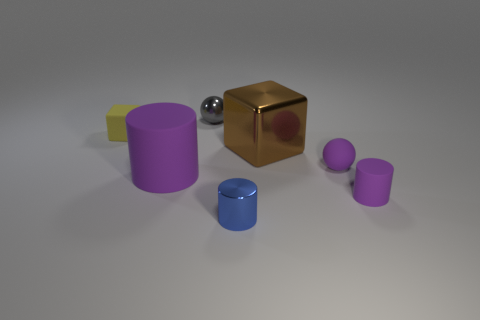Add 2 large cylinders. How many objects exist? 9 Subtract all cylinders. How many objects are left? 4 Add 2 small purple cylinders. How many small purple cylinders are left? 3 Add 6 gray metallic balls. How many gray metallic balls exist? 7 Subtract 0 gray blocks. How many objects are left? 7 Subtract all metal cubes. Subtract all matte blocks. How many objects are left? 5 